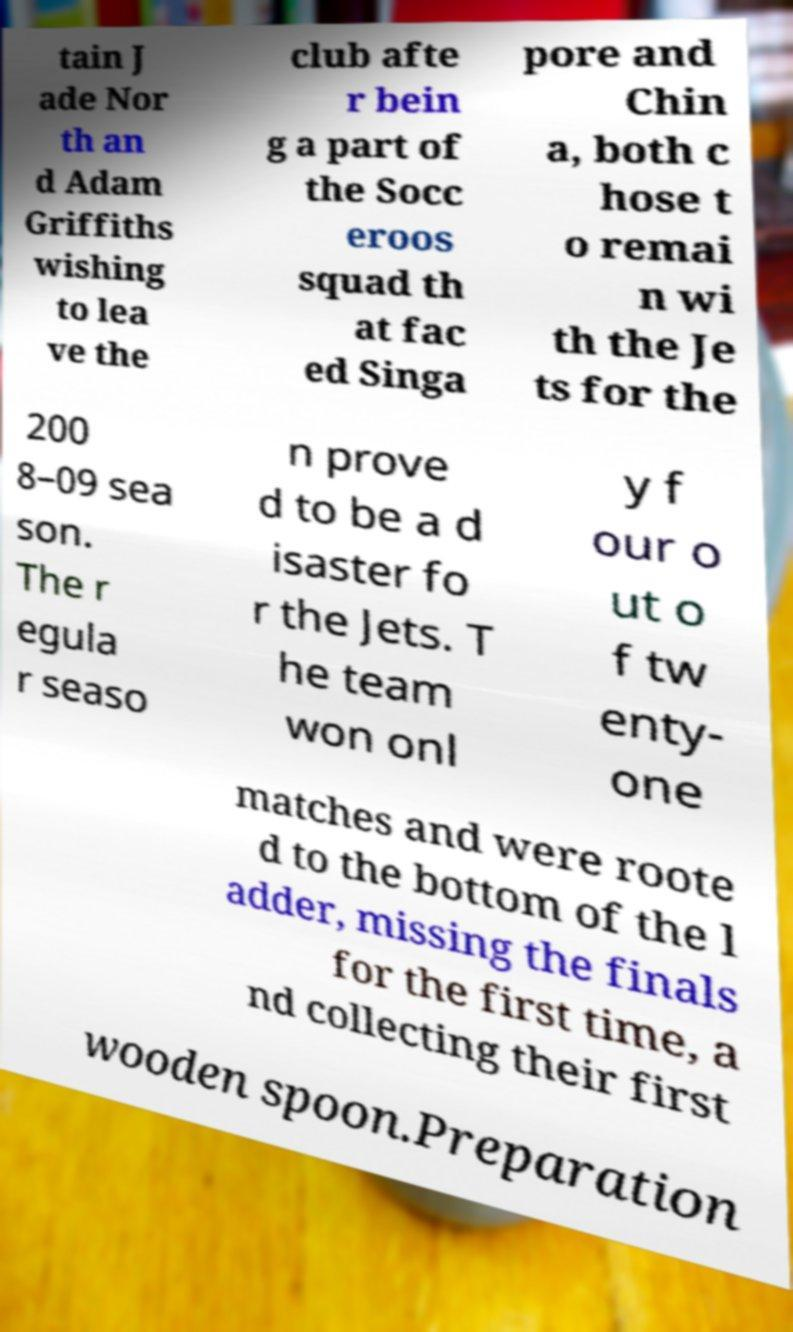Can you accurately transcribe the text from the provided image for me? tain J ade Nor th an d Adam Griffiths wishing to lea ve the club afte r bein g a part of the Socc eroos squad th at fac ed Singa pore and Chin a, both c hose t o remai n wi th the Je ts for the 200 8–09 sea son. The r egula r seaso n prove d to be a d isaster fo r the Jets. T he team won onl y f our o ut o f tw enty- one matches and were roote d to the bottom of the l adder, missing the finals for the first time, a nd collecting their first wooden spoon.Preparation 